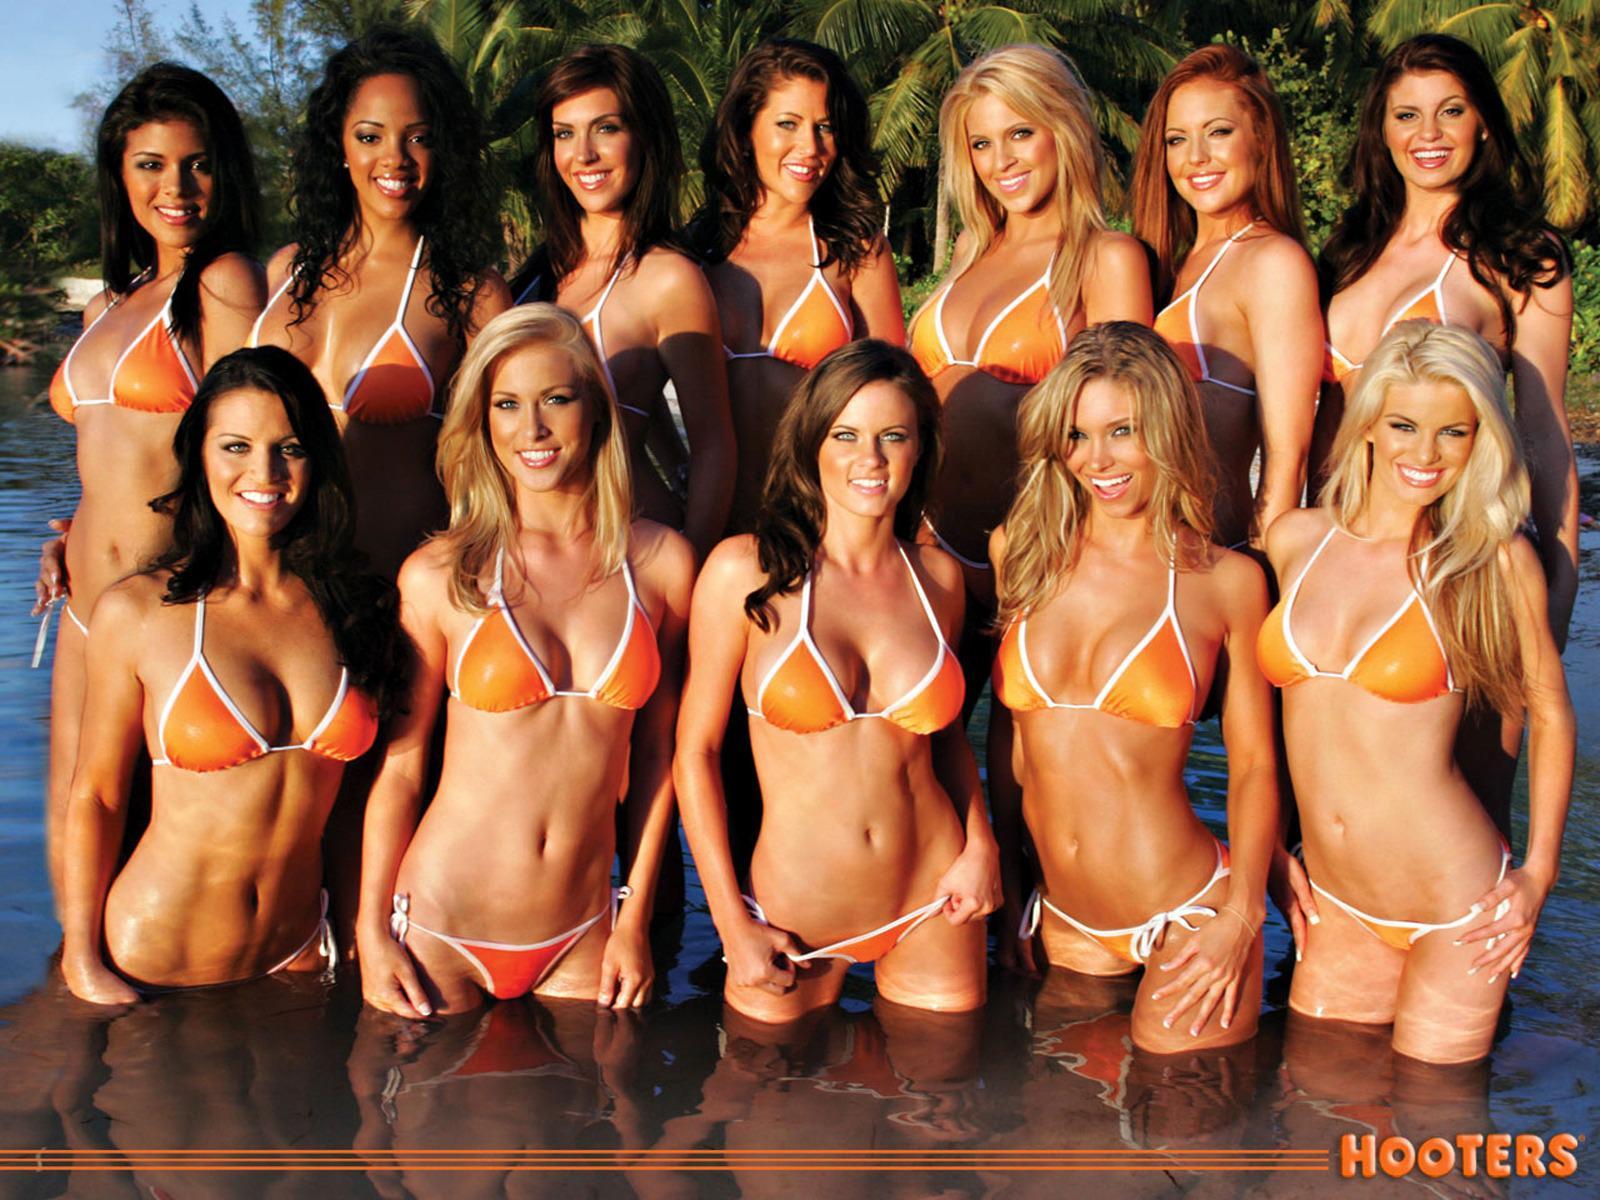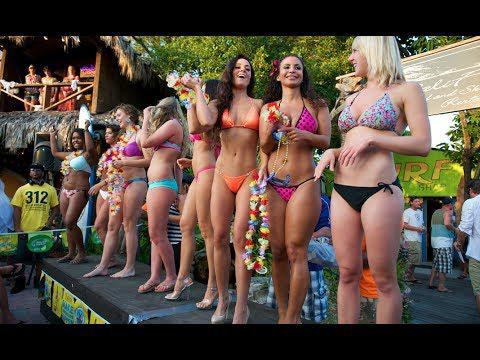The first image is the image on the left, the second image is the image on the right. Given the left and right images, does the statement "Two women are posing in bikinis in the image on the left." hold true? Answer yes or no. No. The first image is the image on the left, the second image is the image on the right. Examine the images to the left and right. Is the description "An image shows exactly three bikini models posed side-by-side, and at least one wears an orange bikini bottom." accurate? Answer yes or no. No. 